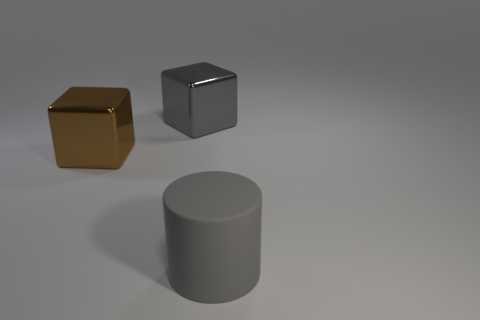Add 3 large things. How many objects exist? 6 Subtract all cylinders. How many objects are left? 2 Subtract all small yellow metal spheres. Subtract all big gray things. How many objects are left? 1 Add 3 large brown metallic cubes. How many large brown metallic cubes are left? 4 Add 3 big shiny cubes. How many big shiny cubes exist? 5 Subtract 0 yellow spheres. How many objects are left? 3 